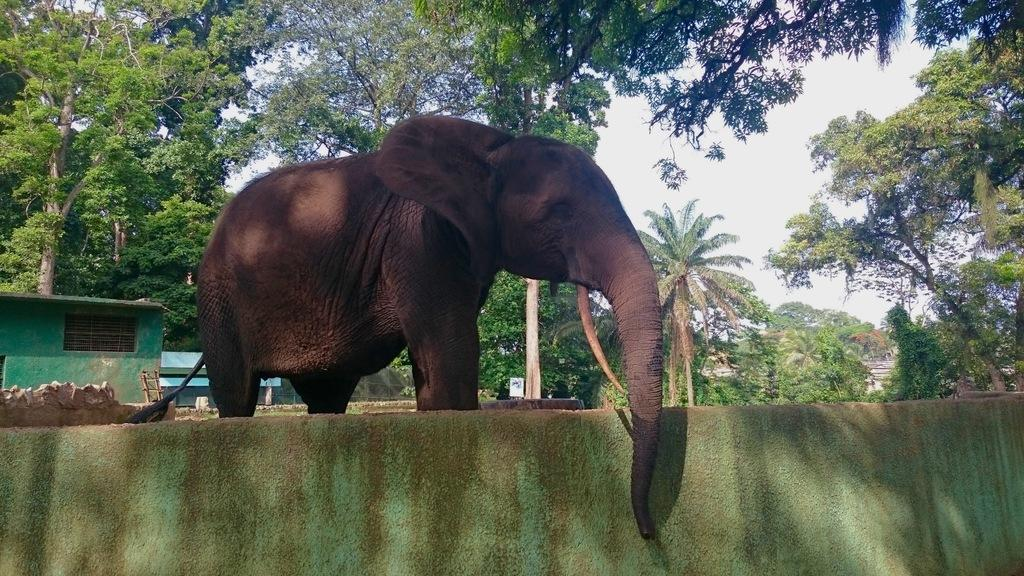What animal is present in the image? There is an elephant in the image. Where is the elephant located in relation to other objects? The elephant is standing behind a wall. What can be seen in the distance in the image? There are houses and trees in the background of the image. What is the condition of the sky in the image? The sky is clear and visible in the background of the image. What type of flowers can be seen growing on the elephant's back in the image? There are no flowers visible on the elephant's back in the image. What kind of plant is the elephant using to knit a sweater in the image? There is no plant or sweater present in the image; it features an elephant standing behind a wall. 